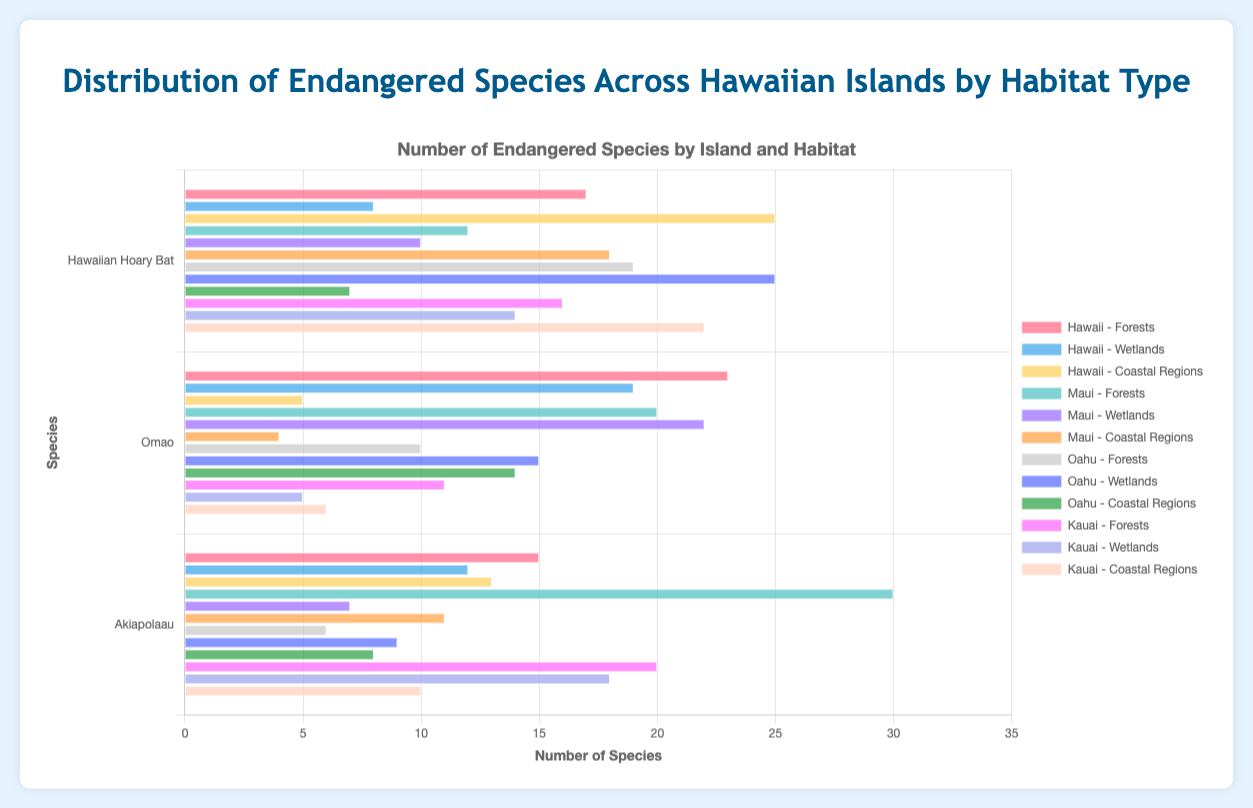What is the most common species in coastal regions on the Hawaiian Island of Hawaii? By looking at the bars associated with Hawaii in the coastal regions category, we see the counts for each species: Green Sea Turtle with 25, Hawaiian Monk Seal with 5, and Hawaiian Hawk with 13. The Green Sea Turtle has the highest count of 25.
Answer: Green Sea Turtle Which island has the highest count of endangered species in forest habitats? We need to compare the total number of species in forest habitats across all islands. Summing up, Hawaii has (17+23+15)=55, Maui has (12+20+30)=62, Oahu has (19+10+6)=35, and Kauai has (16+11+20)=47. Maui has the highest count of 62.
Answer: Maui How many more endangered species are there in forests on Maui compared to wetlands on Oahu? Calculating the totals, Maui forest has 62 species and Oahu wetlands have 25+15+9=49. The difference is 62 - 49 = 13.
Answer: 13 Which habitat type on Oahu supports the most endangered species? Comparing the total counts within Oahu for forests, wetlands, and coastal regions: Forests (19+10+6)=35, Wetlands (25+15+9)=49, and Coastal Regions (7+14+8)=29. Wetlands have the highest count of 49.
Answer: Wetlands What is the average number of species in coastal regions across all islands? Adding counts from all islands' coastal regions and dividing by the number of islands: (25+5+13) for Hawaii, (18+4+11) for Maui, (7+14+8) for Oahu, and (22+6+10) for Kauai. Summing these: 43 + 33 + 29 + 38 = 143, and dividing by 4 islands, the average is 143/4 = 35.75.
Answer: 35.75 Which species has the smallest population in wetlands on Maui? In the Maui wetlands category: Hawaiian Coot (10), Hawaiian Duck (22), and Black-footed Albatross (7). The smallest population is the Black-footed Albatross with 7.
Answer: Black-footed Albatross How do the total endangered species in coastal regions on Hawaii compare with those on Maui? Summing the endangered species in coastal regions on Hawaii (25+5+13)=43 and on Maui (18+4+11)=33, the total on Hawaii is 43 and on Maui is 33. Hawaii has 10 more.
Answer: Hawaii What is the combined total of endangered species in forest habitats on Oahu and Kauai? Adding totals for forests in Oahu (19+10+6)=35 and Kauai (16+11+20)=47. The combined total is 35 + 47 = 82.
Answer: 82 Which island has the least endangered species in wetlands? Comparing the total counts in wetlands by island: Hawaii (8+19+12)=39, Maui (10+22+7)=39, Oahu (25+15+9)=49, and Kauai (14+5+18)=37. The lowest is Kauai with 37.
Answer: Kauai 